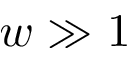<formula> <loc_0><loc_0><loc_500><loc_500>w \gg 1</formula> 